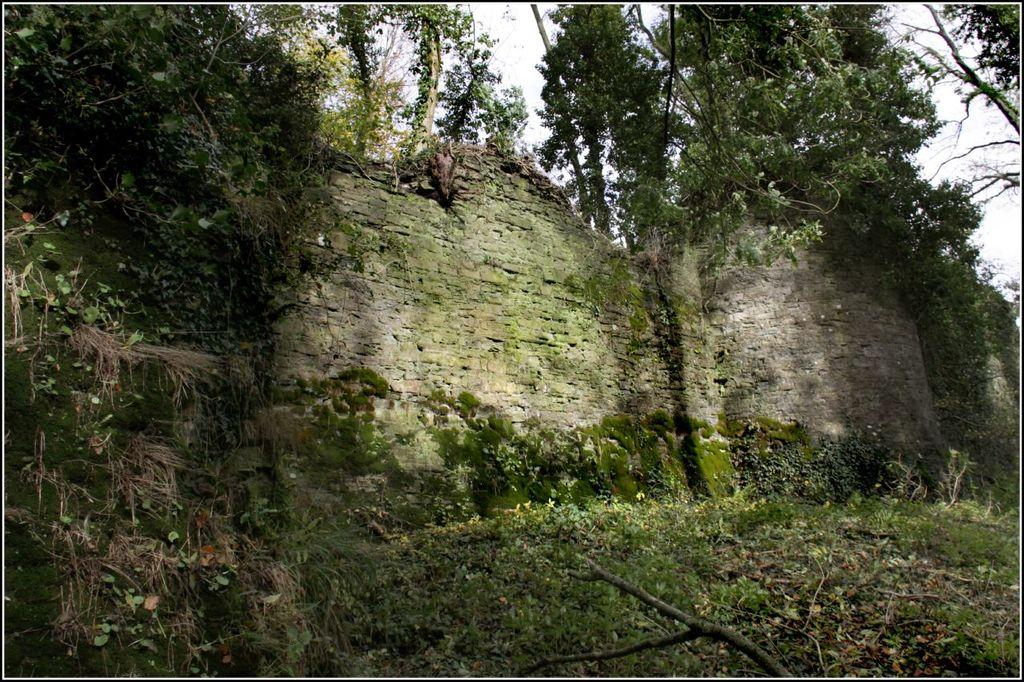What type of vegetation is present in the image? There are plants and trees in the image. What else can be seen in the image besides vegetation? There are walls in the image. How many brothers are depicted in the image? There are no people, let alone brothers, present in the image. 